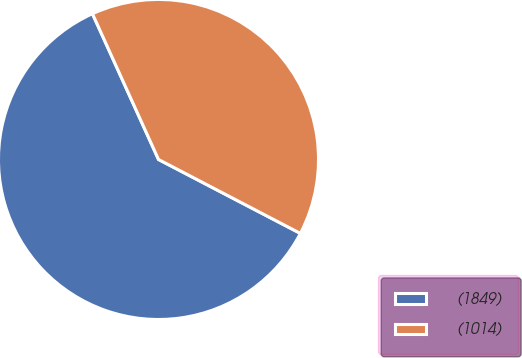<chart> <loc_0><loc_0><loc_500><loc_500><pie_chart><fcel>(1849)<fcel>(1014)<nl><fcel>60.58%<fcel>39.42%<nl></chart> 